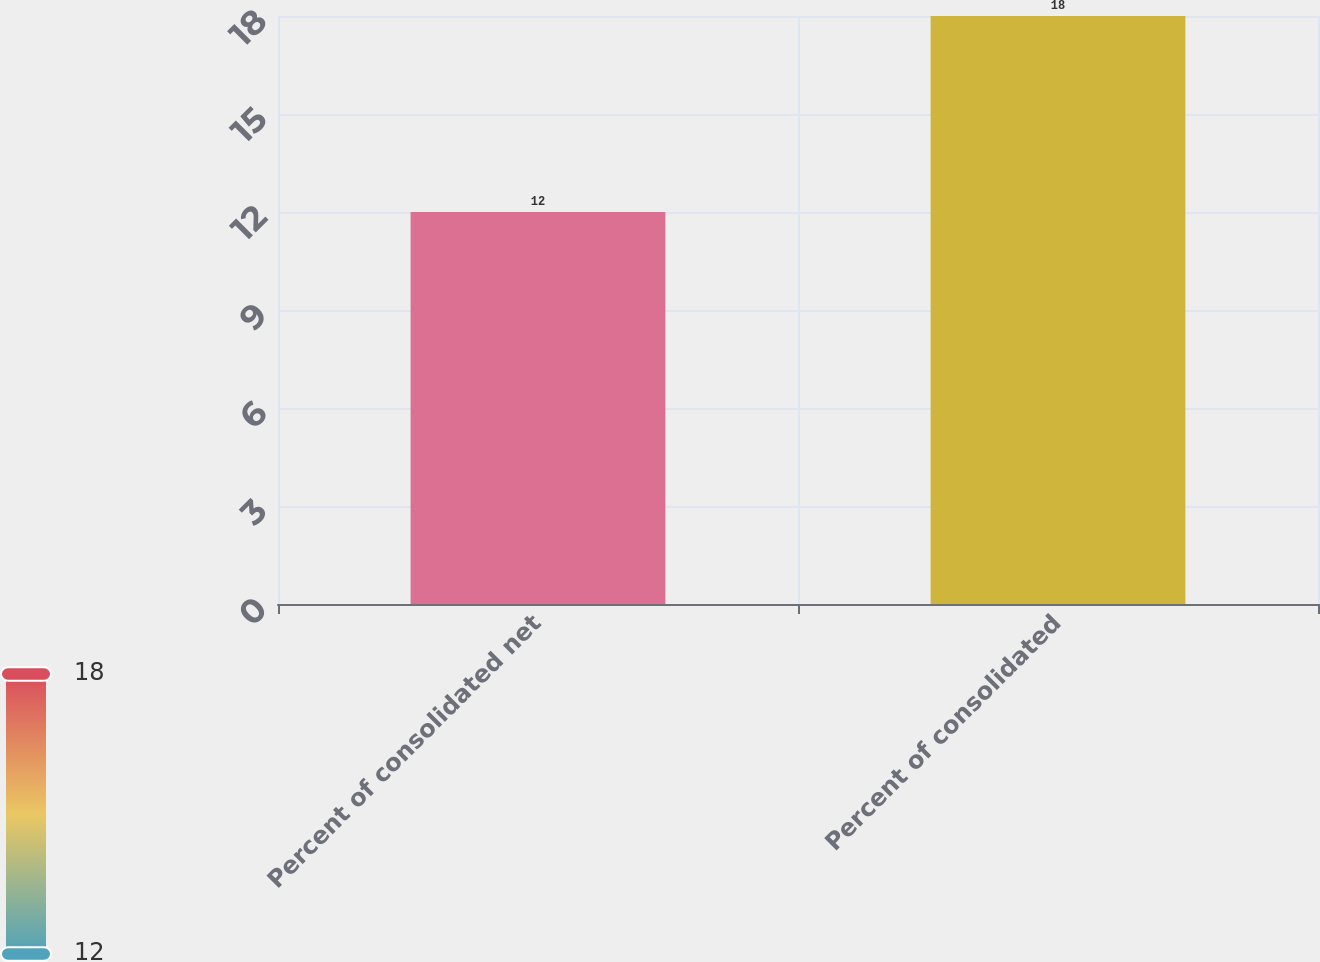Convert chart to OTSL. <chart><loc_0><loc_0><loc_500><loc_500><bar_chart><fcel>Percent of consolidated net<fcel>Percent of consolidated<nl><fcel>12<fcel>18<nl></chart> 